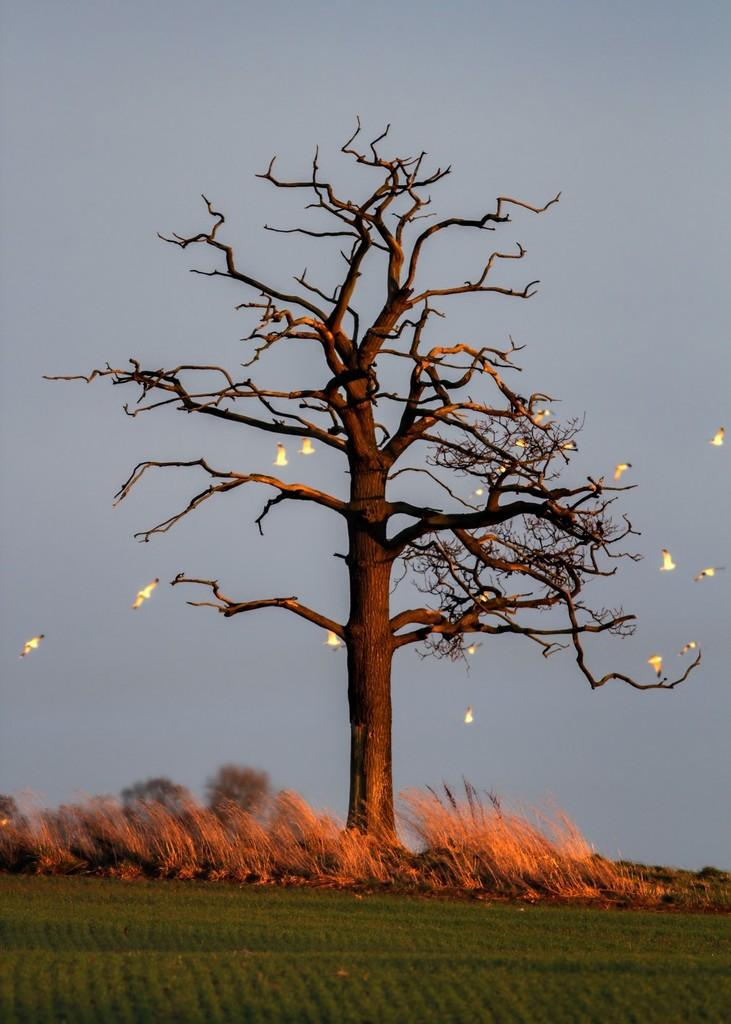What type of plant can be seen in the image? There is a tree in the image. What animals are present in the image? Birds are present in the image. What is located at the bottom of the image? There are dried plants at the bottom of the image. What type of vegetation is visible on the ground? Grass is visible on the ground. What can be seen in the background of the image? The sky is visible in the background of the image. What type of stew is being prepared by the creator in the image? There is no stew or creator present in the image; it features a tree, birds, dried plants, grass, and the sky. What color is the leaf on the tree in the image? There is no specific leaf mentioned in the image, but the tree is present. 